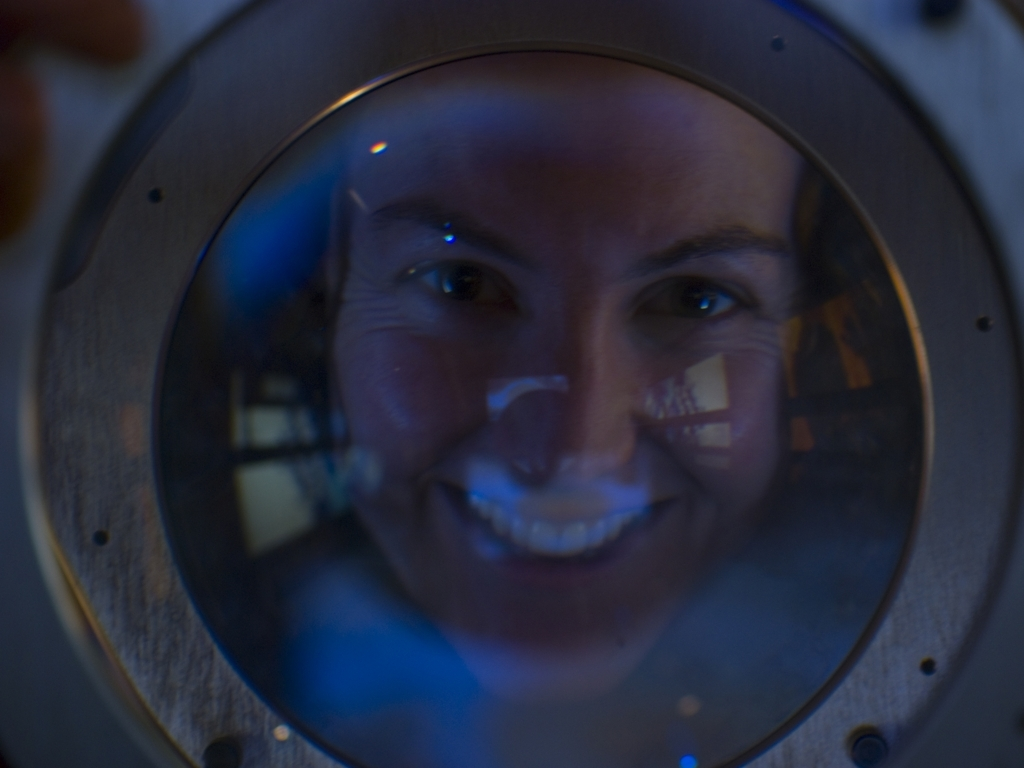Are there any quality issues with this image? Yes, there are noticeable quality issues with this image, including blurriness, potential motion blur, low lighting, and possibly a reflection or refraction effect due to the surface between the camera and the subject, which is obscuring clarity. 